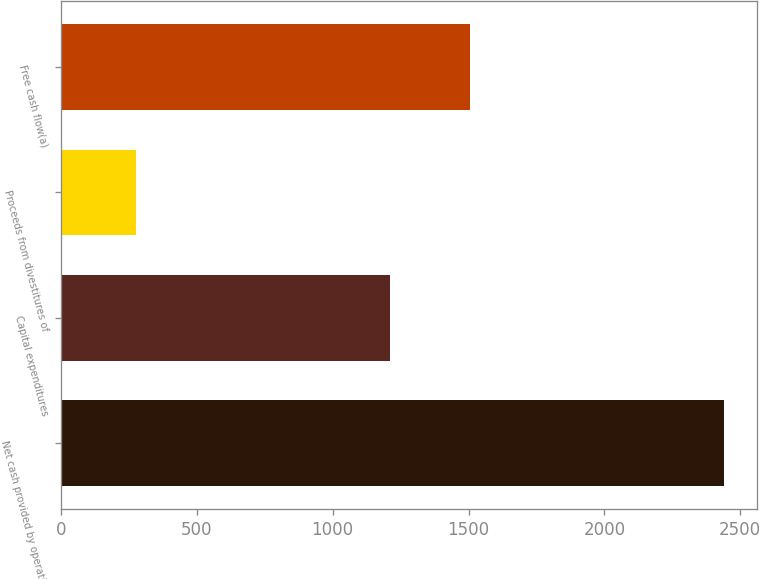Convert chart. <chart><loc_0><loc_0><loc_500><loc_500><bar_chart><fcel>Net cash provided by operating<fcel>Capital expenditures<fcel>Proceeds from divestitures of<fcel>Free cash flow(a)<nl><fcel>2439<fcel>1211<fcel>278<fcel>1506<nl></chart> 